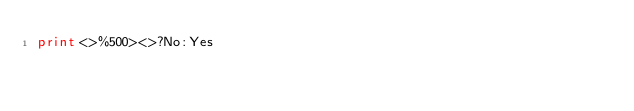<code> <loc_0><loc_0><loc_500><loc_500><_Perl_>print<>%500><>?No:Yes</code> 